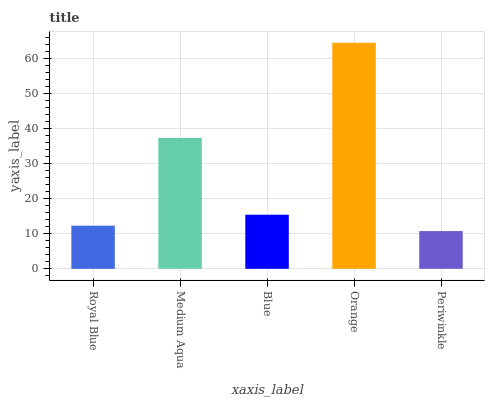Is Periwinkle the minimum?
Answer yes or no. Yes. Is Orange the maximum?
Answer yes or no. Yes. Is Medium Aqua the minimum?
Answer yes or no. No. Is Medium Aqua the maximum?
Answer yes or no. No. Is Medium Aqua greater than Royal Blue?
Answer yes or no. Yes. Is Royal Blue less than Medium Aqua?
Answer yes or no. Yes. Is Royal Blue greater than Medium Aqua?
Answer yes or no. No. Is Medium Aqua less than Royal Blue?
Answer yes or no. No. Is Blue the high median?
Answer yes or no. Yes. Is Blue the low median?
Answer yes or no. Yes. Is Orange the high median?
Answer yes or no. No. Is Medium Aqua the low median?
Answer yes or no. No. 